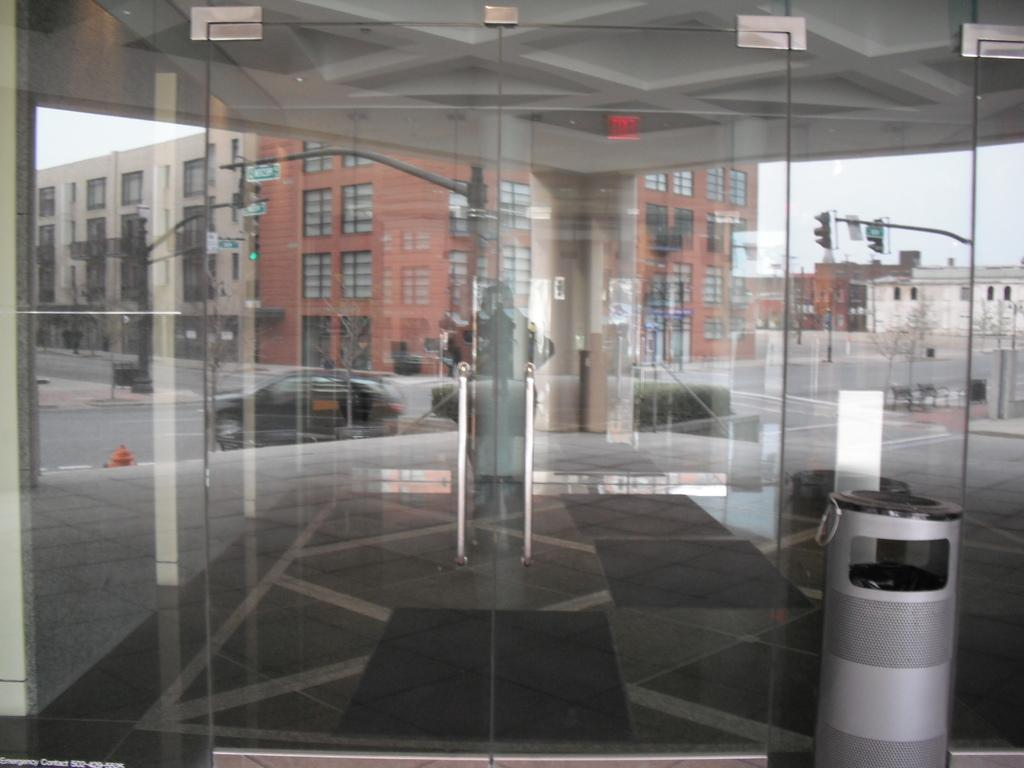What type of door is present in the image? There is a glass door in the image. What can be seen through the glass door? Buildings, a road, and signal lights are visible through the glass door. What type of wheel is visible on the moon in the image? There is no wheel or moon present in the image; it features a glass door with views of buildings, a road, and signal lights. 